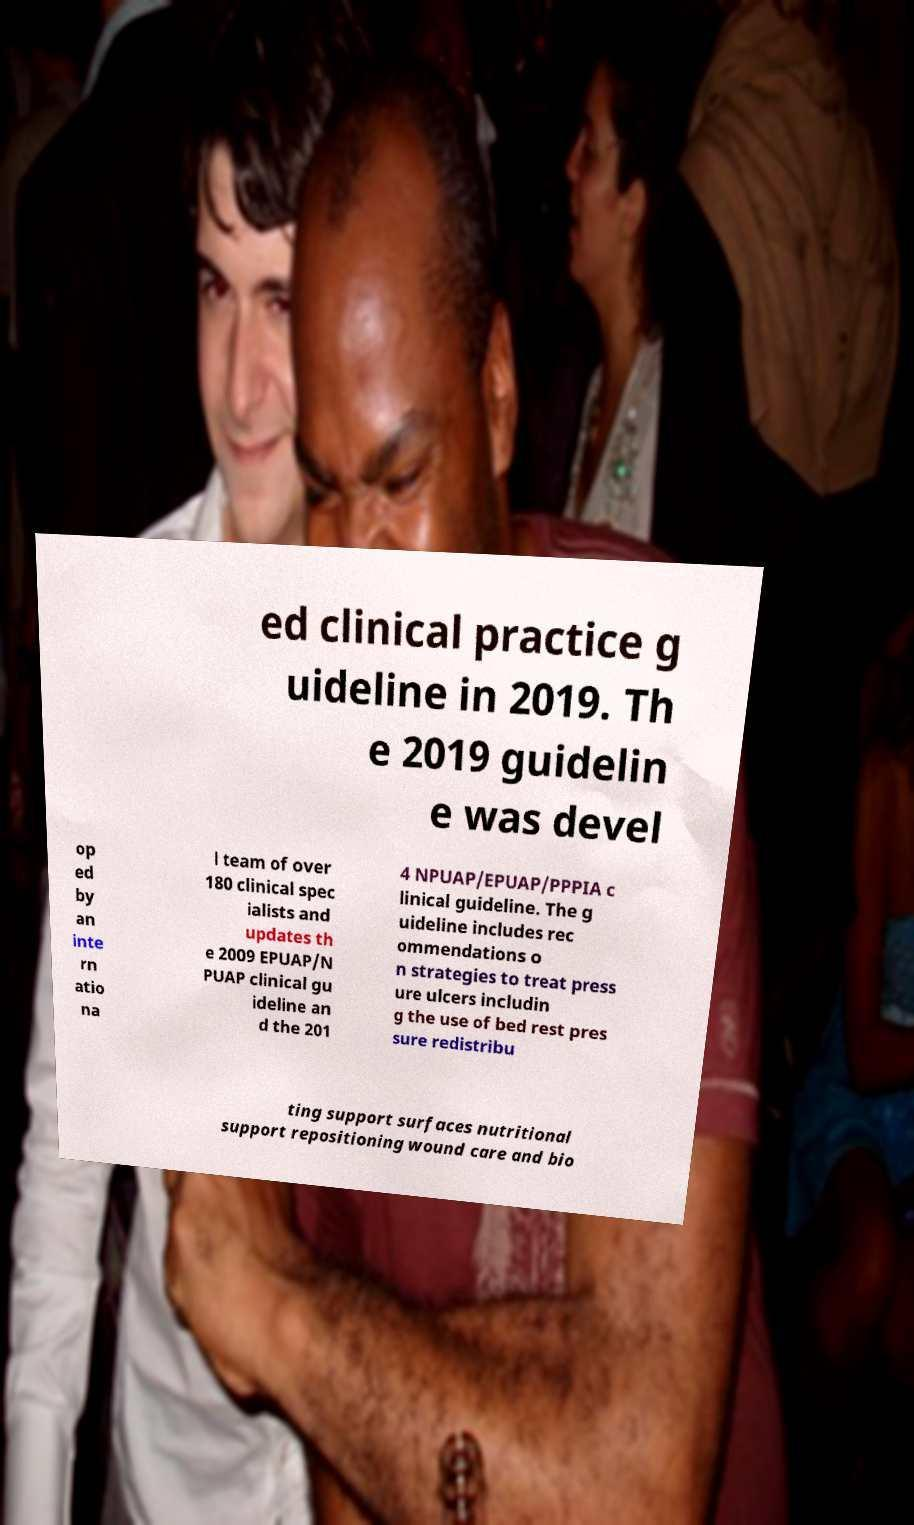For documentation purposes, I need the text within this image transcribed. Could you provide that? ed clinical practice g uideline in 2019. Th e 2019 guidelin e was devel op ed by an inte rn atio na l team of over 180 clinical spec ialists and updates th e 2009 EPUAP/N PUAP clinical gu ideline an d the 201 4 NPUAP/EPUAP/PPPIA c linical guideline. The g uideline includes rec ommendations o n strategies to treat press ure ulcers includin g the use of bed rest pres sure redistribu ting support surfaces nutritional support repositioning wound care and bio 